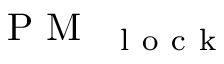<formula> <loc_0><loc_0><loc_500><loc_500>P M _ { { l o c k } }</formula> 